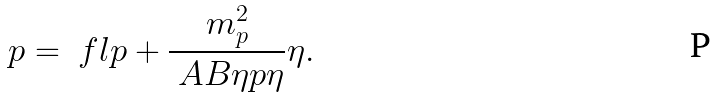Convert formula to latex. <formula><loc_0><loc_0><loc_500><loc_500>p = \ f l p + \frac { m _ { p } ^ { 2 } } { \ A B { \eta } { p } { \eta } } \eta .</formula> 